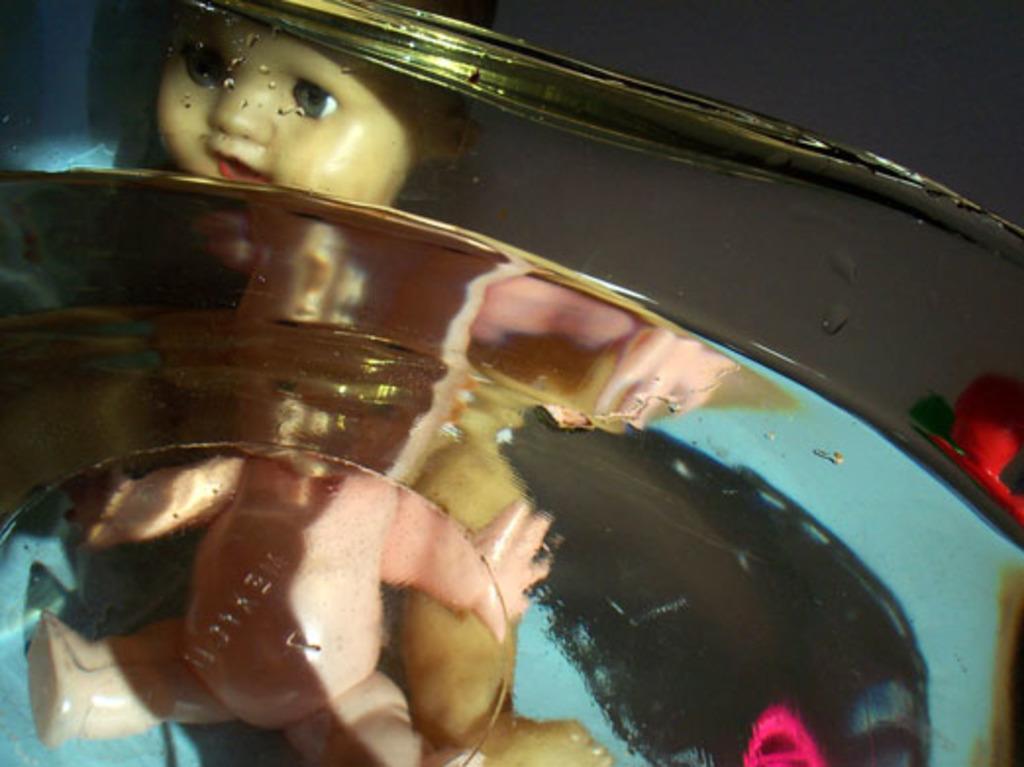In one or two sentences, can you explain what this image depicts? In this image there is a doll behind a glass material. 